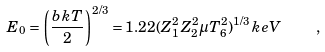<formula> <loc_0><loc_0><loc_500><loc_500>E _ { 0 } = \left ( \frac { b k T } { 2 } \right ) ^ { 2 / 3 } = 1 . 2 2 ( Z _ { 1 } ^ { 2 } Z _ { 2 } ^ { 2 } \mu T _ { 6 } ^ { 2 } ) ^ { 1 / 3 } \, k e V \quad ,</formula> 